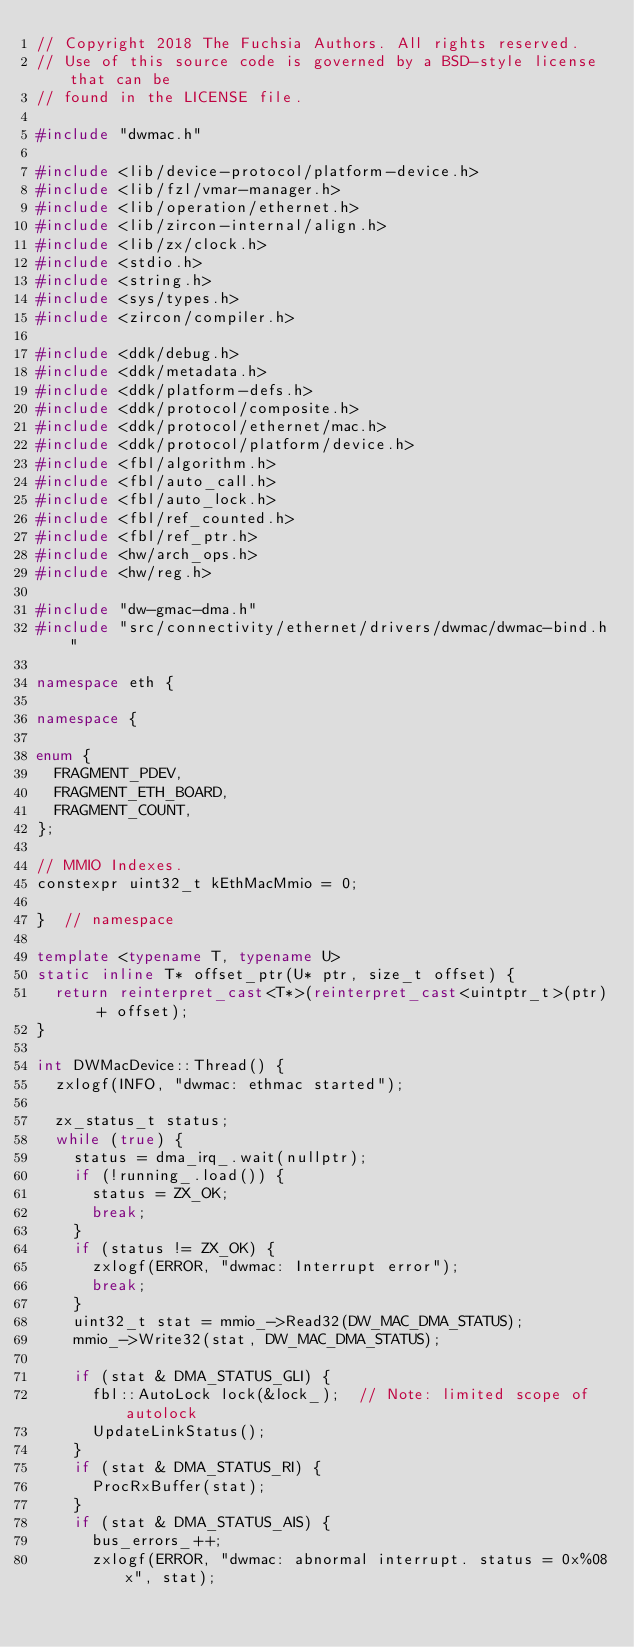Convert code to text. <code><loc_0><loc_0><loc_500><loc_500><_C++_>// Copyright 2018 The Fuchsia Authors. All rights reserved.
// Use of this source code is governed by a BSD-style license that can be
// found in the LICENSE file.

#include "dwmac.h"

#include <lib/device-protocol/platform-device.h>
#include <lib/fzl/vmar-manager.h>
#include <lib/operation/ethernet.h>
#include <lib/zircon-internal/align.h>
#include <lib/zx/clock.h>
#include <stdio.h>
#include <string.h>
#include <sys/types.h>
#include <zircon/compiler.h>

#include <ddk/debug.h>
#include <ddk/metadata.h>
#include <ddk/platform-defs.h>
#include <ddk/protocol/composite.h>
#include <ddk/protocol/ethernet/mac.h>
#include <ddk/protocol/platform/device.h>
#include <fbl/algorithm.h>
#include <fbl/auto_call.h>
#include <fbl/auto_lock.h>
#include <fbl/ref_counted.h>
#include <fbl/ref_ptr.h>
#include <hw/arch_ops.h>
#include <hw/reg.h>

#include "dw-gmac-dma.h"
#include "src/connectivity/ethernet/drivers/dwmac/dwmac-bind.h"

namespace eth {

namespace {

enum {
  FRAGMENT_PDEV,
  FRAGMENT_ETH_BOARD,
  FRAGMENT_COUNT,
};

// MMIO Indexes.
constexpr uint32_t kEthMacMmio = 0;

}  // namespace

template <typename T, typename U>
static inline T* offset_ptr(U* ptr, size_t offset) {
  return reinterpret_cast<T*>(reinterpret_cast<uintptr_t>(ptr) + offset);
}

int DWMacDevice::Thread() {
  zxlogf(INFO, "dwmac: ethmac started");

  zx_status_t status;
  while (true) {
    status = dma_irq_.wait(nullptr);
    if (!running_.load()) {
      status = ZX_OK;
      break;
    }
    if (status != ZX_OK) {
      zxlogf(ERROR, "dwmac: Interrupt error");
      break;
    }
    uint32_t stat = mmio_->Read32(DW_MAC_DMA_STATUS);
    mmio_->Write32(stat, DW_MAC_DMA_STATUS);

    if (stat & DMA_STATUS_GLI) {
      fbl::AutoLock lock(&lock_);  // Note: limited scope of autolock
      UpdateLinkStatus();
    }
    if (stat & DMA_STATUS_RI) {
      ProcRxBuffer(stat);
    }
    if (stat & DMA_STATUS_AIS) {
      bus_errors_++;
      zxlogf(ERROR, "dwmac: abnormal interrupt. status = 0x%08x", stat);</code> 